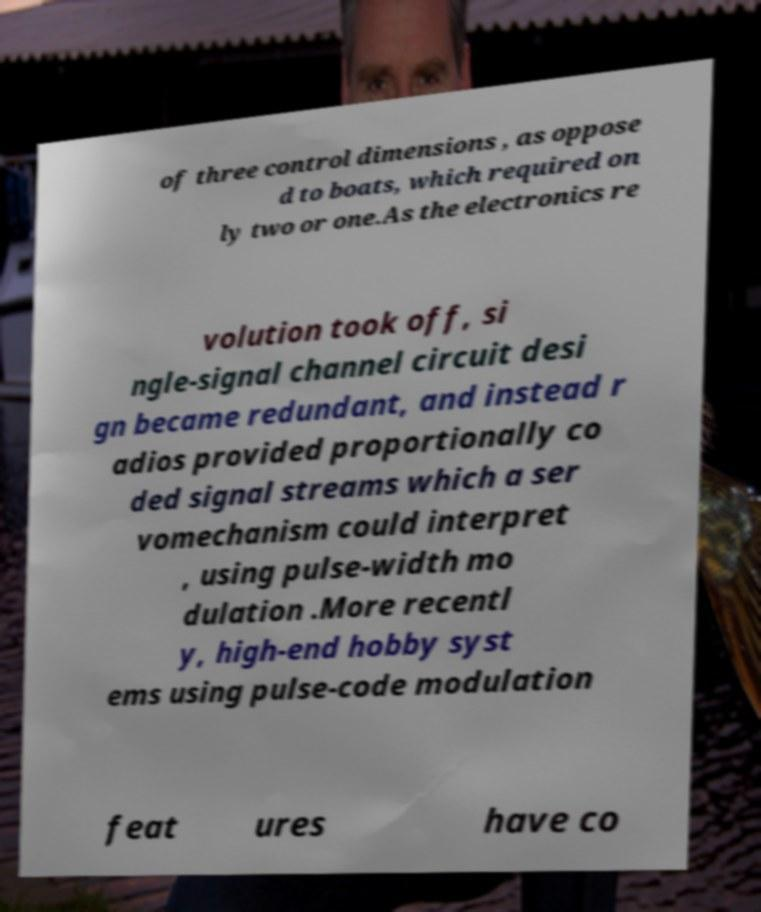Can you accurately transcribe the text from the provided image for me? of three control dimensions , as oppose d to boats, which required on ly two or one.As the electronics re volution took off, si ngle-signal channel circuit desi gn became redundant, and instead r adios provided proportionally co ded signal streams which a ser vomechanism could interpret , using pulse-width mo dulation .More recentl y, high-end hobby syst ems using pulse-code modulation feat ures have co 